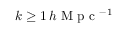Convert formula to latex. <formula><loc_0><loc_0><loc_500><loc_500>k \geq 1 \, h M p c { ^ { - 1 } }</formula> 